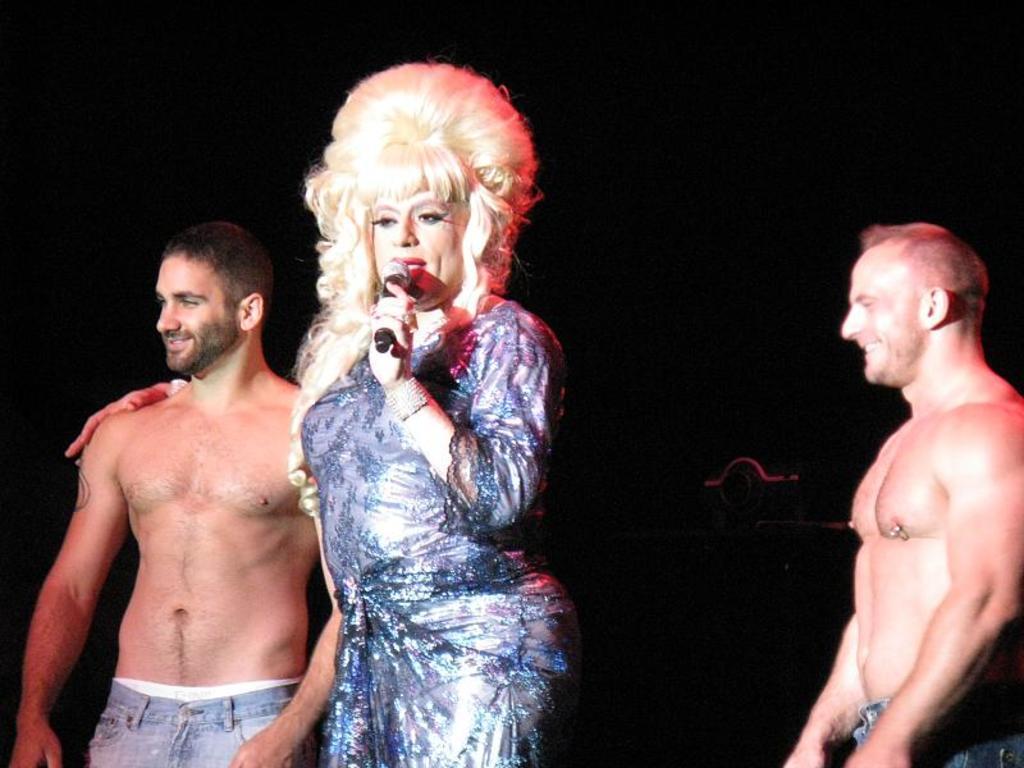Could you give a brief overview of what you see in this image? In this image we can see three persons standing. One woman wearing dress is holding a microphone in her hand. 